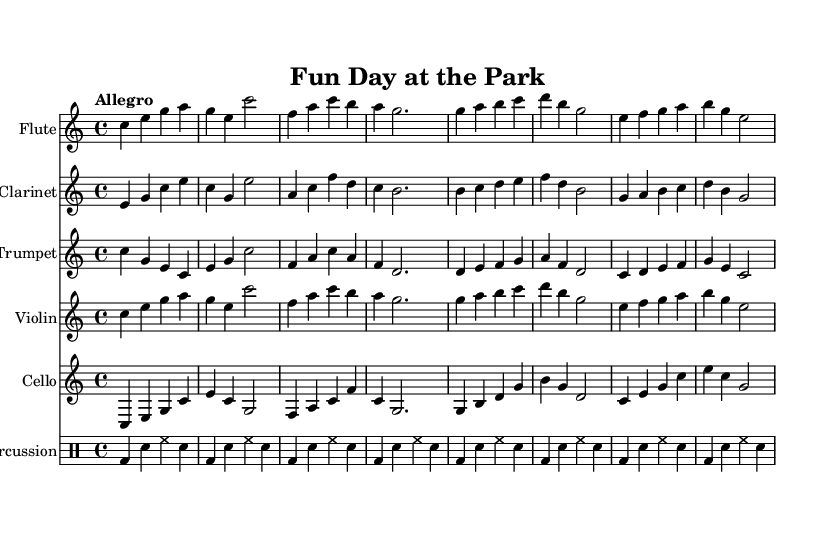What is the key signature of this music? The key signature is C major, which has no sharps or flats.
Answer: C major What is the time signature of this music? The time signature is indicated as 4/4, which means there are four beats in each measure and the quarter note gets one beat.
Answer: 4/4 What is the tempo marking for this piece? The tempo marking at the beginning indicates "Allegro," which translates to a fast and lively pace.
Answer: Allegro Which instruments are featured in this sheet music? The sheet music includes flute, clarinet, trumpet, violin, cello, and percussion, as indicated by the instrument names at the beginning of each staff.
Answer: Flute, clarinet, trumpet, violin, cello, percussion How many measures does the flute part contain? By counting the measures in the flute part, we can see it contains eight measures, as divided by the vertical lines on the staff.
Answer: Eight Which instrument plays the first note of the piece? The flute plays the first note, which is a C, as observed in the initial measure of the flute part.
Answer: Flute How would you describe the overall mood of this piece? The music has a cheerful and playful character, reflecting the lively atmosphere of an amusement park, indicated by the upbeat tempo and major key.
Answer: Cheerful 